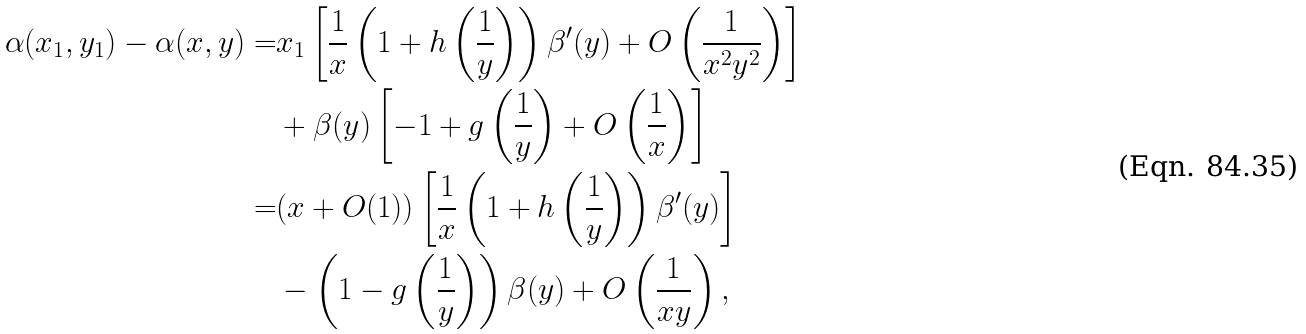Convert formula to latex. <formula><loc_0><loc_0><loc_500><loc_500>\alpha ( x _ { 1 } , y _ { 1 } ) - \alpha ( x , y ) = & x _ { 1 } \left [ \frac { 1 } { x } \left ( 1 + h \left ( \frac { 1 } { y } \right ) \right ) \beta ^ { \prime } ( y ) + O \left ( \frac { 1 } { x ^ { 2 } y ^ { 2 } } \right ) \right ] \\ & + \beta ( y ) \left [ - 1 + g \left ( \frac { 1 } { y } \right ) + O \left ( \frac { 1 } { x } \right ) \right ] \\ = & ( x + O ( 1 ) ) \left [ \frac { 1 } { x } \left ( 1 + h \left ( \frac { 1 } { y } \right ) \right ) \beta ^ { \prime } ( y ) \right ] \\ & - \left ( 1 - g \left ( \frac { 1 } { y } \right ) \right ) \beta ( y ) + O \left ( \frac { 1 } { x y } \right ) ,</formula> 